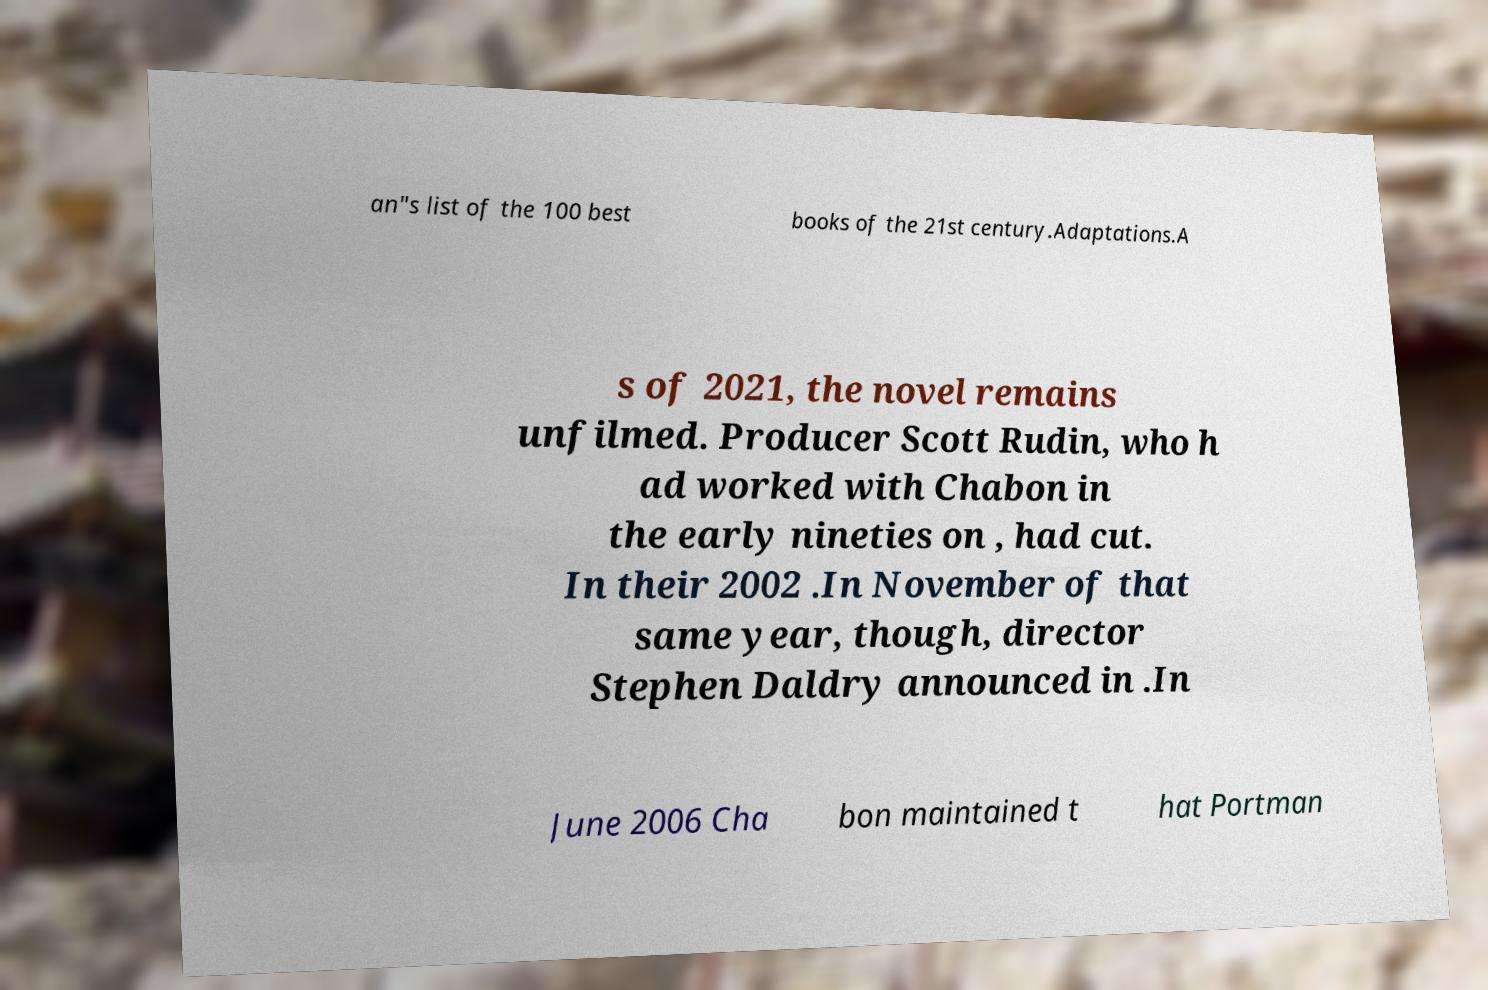I need the written content from this picture converted into text. Can you do that? an"s list of the 100 best books of the 21st century.Adaptations.A s of 2021, the novel remains unfilmed. Producer Scott Rudin, who h ad worked with Chabon in the early nineties on , had cut. In their 2002 .In November of that same year, though, director Stephen Daldry announced in .In June 2006 Cha bon maintained t hat Portman 